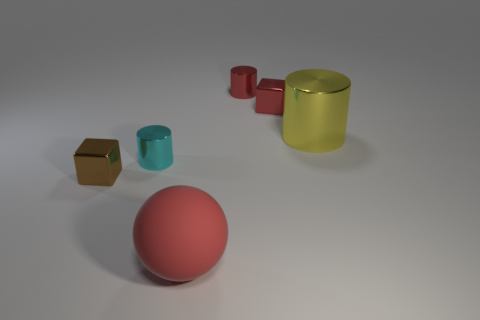Add 3 tiny shiny cubes. How many objects exist? 9 Subtract all blocks. How many objects are left? 4 Add 3 small brown cubes. How many small brown cubes are left? 4 Add 1 large rubber objects. How many large rubber objects exist? 2 Subtract 1 cyan cylinders. How many objects are left? 5 Subtract all gray rubber cylinders. Subtract all blocks. How many objects are left? 4 